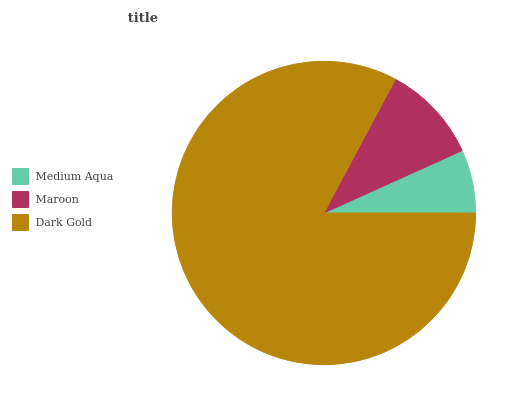Is Medium Aqua the minimum?
Answer yes or no. Yes. Is Dark Gold the maximum?
Answer yes or no. Yes. Is Maroon the minimum?
Answer yes or no. No. Is Maroon the maximum?
Answer yes or no. No. Is Maroon greater than Medium Aqua?
Answer yes or no. Yes. Is Medium Aqua less than Maroon?
Answer yes or no. Yes. Is Medium Aqua greater than Maroon?
Answer yes or no. No. Is Maroon less than Medium Aqua?
Answer yes or no. No. Is Maroon the high median?
Answer yes or no. Yes. Is Maroon the low median?
Answer yes or no. Yes. Is Dark Gold the high median?
Answer yes or no. No. Is Medium Aqua the low median?
Answer yes or no. No. 